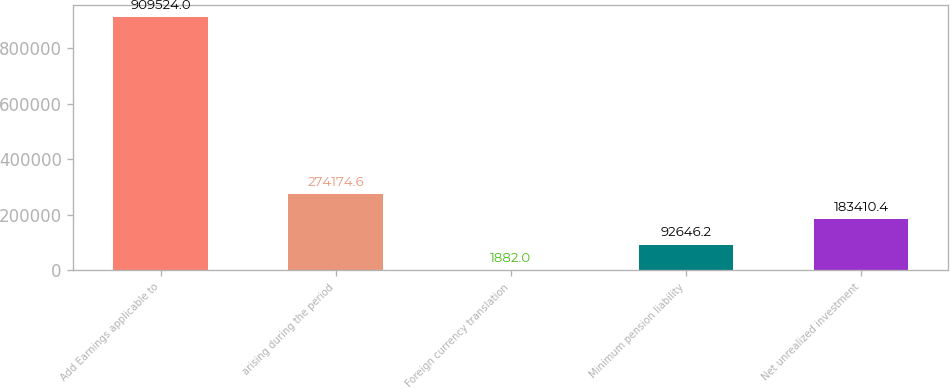<chart> <loc_0><loc_0><loc_500><loc_500><bar_chart><fcel>Add Earnings applicable to<fcel>arising during the period<fcel>Foreign currency translation<fcel>Minimum pension liability<fcel>Net unrealized investment<nl><fcel>909524<fcel>274175<fcel>1882<fcel>92646.2<fcel>183410<nl></chart> 